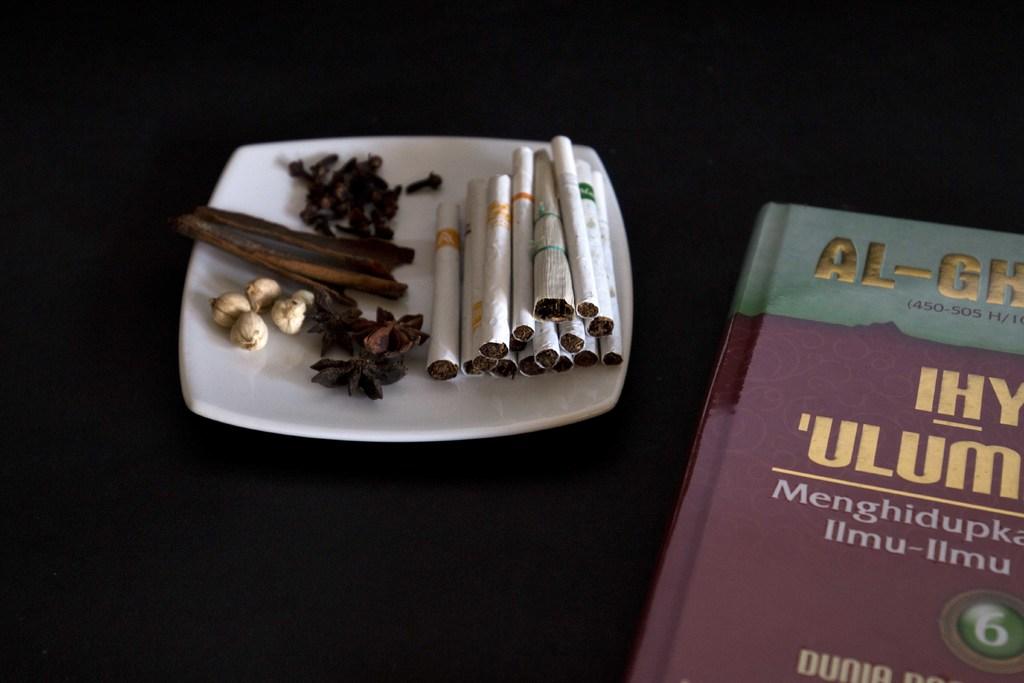What volume number is the book?
Provide a succinct answer. 6. What is the title of the book, as visibie?
Give a very brief answer. Unanswerable. 